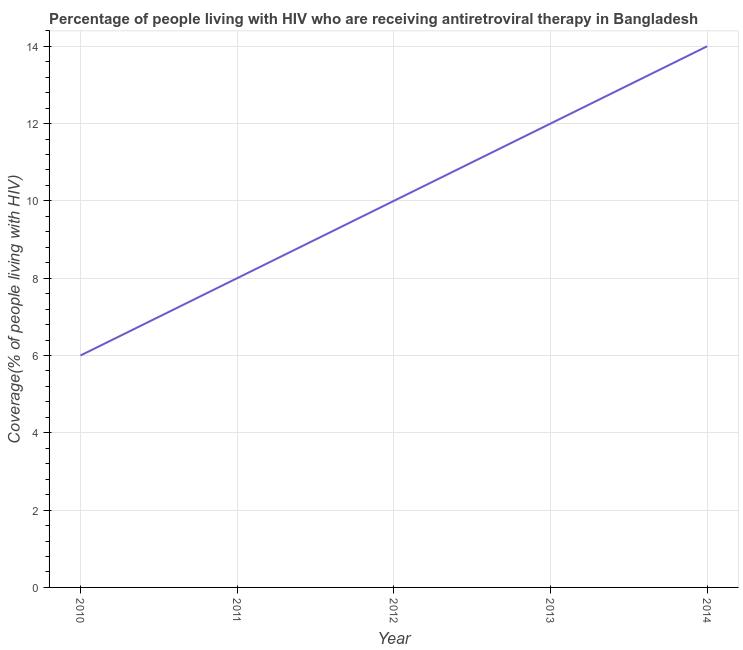What is the antiretroviral therapy coverage in 2013?
Your response must be concise. 12. Across all years, what is the maximum antiretroviral therapy coverage?
Your answer should be very brief. 14. Across all years, what is the minimum antiretroviral therapy coverage?
Keep it short and to the point. 6. In which year was the antiretroviral therapy coverage minimum?
Your answer should be very brief. 2010. What is the sum of the antiretroviral therapy coverage?
Give a very brief answer. 50. What is the difference between the antiretroviral therapy coverage in 2011 and 2012?
Offer a terse response. -2. What is the average antiretroviral therapy coverage per year?
Your response must be concise. 10. What is the median antiretroviral therapy coverage?
Ensure brevity in your answer.  10. In how many years, is the antiretroviral therapy coverage greater than 4.8 %?
Provide a succinct answer. 5. Do a majority of the years between 2011 and 2014 (inclusive) have antiretroviral therapy coverage greater than 6 %?
Offer a terse response. Yes. What is the ratio of the antiretroviral therapy coverage in 2012 to that in 2013?
Your response must be concise. 0.83. Is the antiretroviral therapy coverage in 2012 less than that in 2014?
Your response must be concise. Yes. Is the sum of the antiretroviral therapy coverage in 2012 and 2014 greater than the maximum antiretroviral therapy coverage across all years?
Ensure brevity in your answer.  Yes. What is the difference between the highest and the lowest antiretroviral therapy coverage?
Ensure brevity in your answer.  8. Does the antiretroviral therapy coverage monotonically increase over the years?
Offer a very short reply. Yes. What is the difference between two consecutive major ticks on the Y-axis?
Your answer should be compact. 2. What is the title of the graph?
Your answer should be compact. Percentage of people living with HIV who are receiving antiretroviral therapy in Bangladesh. What is the label or title of the Y-axis?
Offer a terse response. Coverage(% of people living with HIV). What is the Coverage(% of people living with HIV) in 2010?
Your response must be concise. 6. What is the Coverage(% of people living with HIV) in 2014?
Your response must be concise. 14. What is the difference between the Coverage(% of people living with HIV) in 2010 and 2013?
Provide a succinct answer. -6. What is the difference between the Coverage(% of people living with HIV) in 2011 and 2012?
Offer a very short reply. -2. What is the difference between the Coverage(% of people living with HIV) in 2011 and 2013?
Keep it short and to the point. -4. What is the difference between the Coverage(% of people living with HIV) in 2011 and 2014?
Offer a very short reply. -6. What is the difference between the Coverage(% of people living with HIV) in 2012 and 2013?
Provide a succinct answer. -2. What is the difference between the Coverage(% of people living with HIV) in 2012 and 2014?
Provide a succinct answer. -4. What is the ratio of the Coverage(% of people living with HIV) in 2010 to that in 2011?
Provide a short and direct response. 0.75. What is the ratio of the Coverage(% of people living with HIV) in 2010 to that in 2012?
Your answer should be compact. 0.6. What is the ratio of the Coverage(% of people living with HIV) in 2010 to that in 2013?
Make the answer very short. 0.5. What is the ratio of the Coverage(% of people living with HIV) in 2010 to that in 2014?
Provide a succinct answer. 0.43. What is the ratio of the Coverage(% of people living with HIV) in 2011 to that in 2013?
Offer a very short reply. 0.67. What is the ratio of the Coverage(% of people living with HIV) in 2011 to that in 2014?
Ensure brevity in your answer.  0.57. What is the ratio of the Coverage(% of people living with HIV) in 2012 to that in 2013?
Your answer should be compact. 0.83. What is the ratio of the Coverage(% of people living with HIV) in 2012 to that in 2014?
Give a very brief answer. 0.71. What is the ratio of the Coverage(% of people living with HIV) in 2013 to that in 2014?
Make the answer very short. 0.86. 